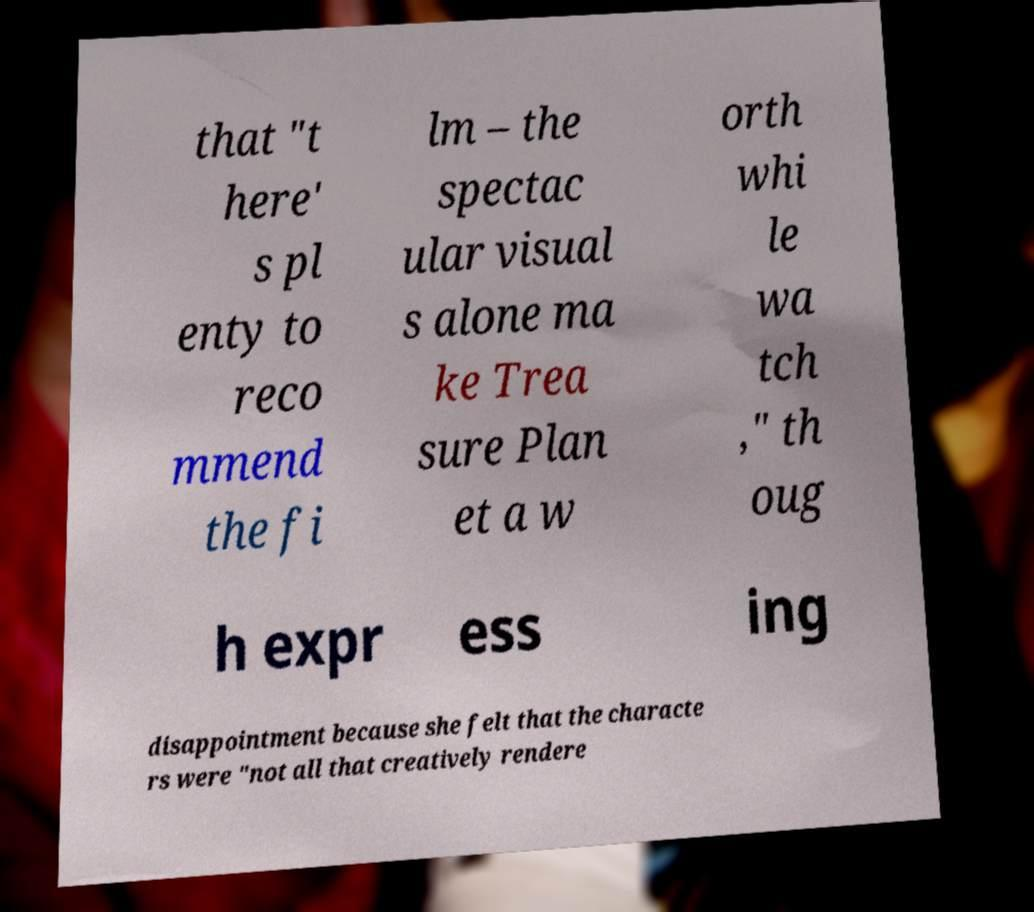Please identify and transcribe the text found in this image. that "t here' s pl enty to reco mmend the fi lm – the spectac ular visual s alone ma ke Trea sure Plan et a w orth whi le wa tch ," th oug h expr ess ing disappointment because she felt that the characte rs were "not all that creatively rendere 